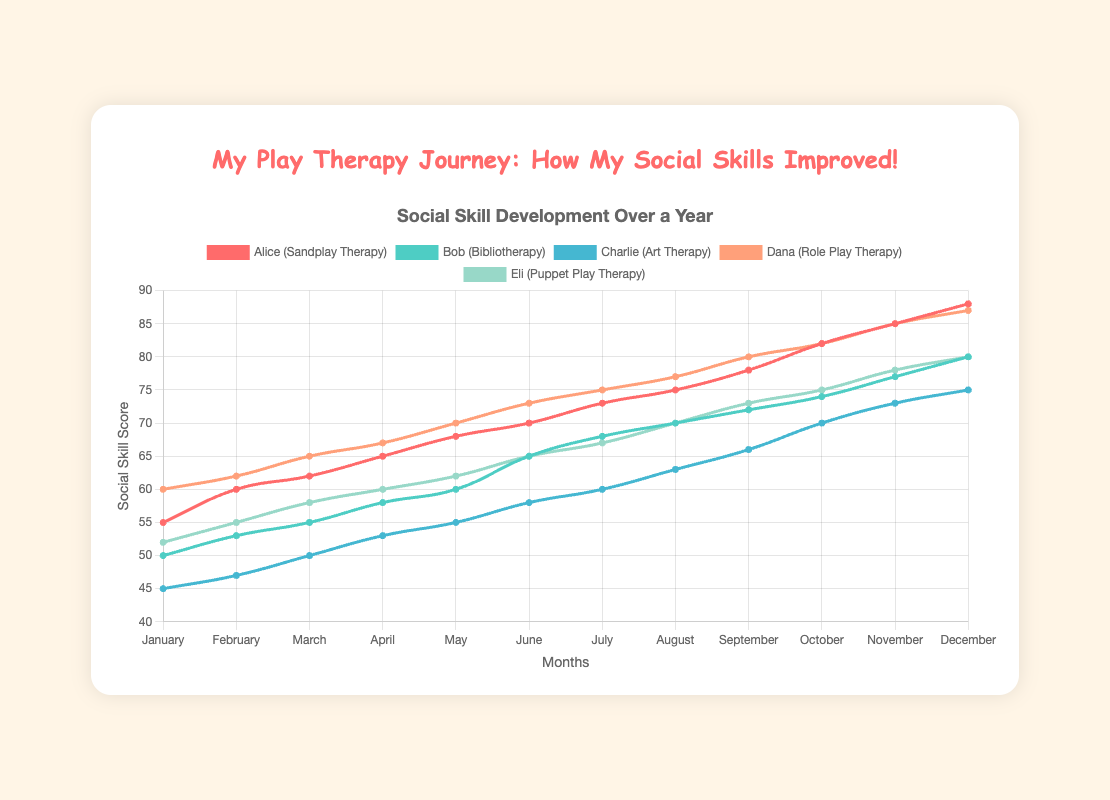Which student showed the greatest increase in their social skill score in December compared to January? To find the greatest increase, subtract the January score from the December score for each student. Alice: 88-55 = 33, Bob: 80-50 = 30, Charlie: 75-45 = 30, Dana: 87-60 = 27, Eli: 80-52 = 28. Thus, Alice shows the greatest increase.
Answer: Alice Who had the highest social skill score in October? Check the values for each student in October. Alice: 82, Bob: 74, Charlie: 70, Dana: 82, Eli: 75. Alice and Dana both have the highest score of 82.
Answer: Alice and Dana What is the average social skill score of Eli over the entire year? To find the average, sum all the scores and divide by the number of months. Eli's scores are 52, 55, 58, 60, 62, 65, 67, 70, 73, 75, 78, 80. Sum = 795. The number of months = 12, so average = 795/12 ≈ 66.25.
Answer: 66.25 Which therapy technique was associated with the lowest initial (January) social skill score? Compare the January scores. Alice (Sandplay Therapy): 55, Bob (Bibliotherapy): 50, Charlie (Art Therapy): 45, Dana (Role Play Therapy): 60, Eli (Puppet Play Therapy): 52. Charlie has the lowest score of 45 with Art Therapy.
Answer: Art Therapy Is there a month where all students had the same or increased social skill scores compared to the previous month? Check each student's scores month by month. In June, Alice: 70 (↑), Bob: 65 (↑), Charlie: 58 (↑), Dana: 73 (↑), Eli: 65 (↑). All students had increased scores in June compared to May.
Answer: June How many months did Alice have the highest social skill score among all students? Compare Alice's scores each month to the other students' scores. Alice had the highest score in April, May, October, November, and December. That's 5 months.
Answer: 5 Which student showed a decrease in their social skill score between any two consecutive months? Look through each student's score month-to-month. All students' scores either increased or stayed the same each month without any decreases.
Answer: None What is the total increase in social skill score for Bob from January to December? Subtract January's score from December's score for Bob. December: 80, January: 50. Total increase = 80 - 50 = 30.
Answer: 30 What is Dana's social skill score in September, and how does it compare to Charlie's score in the same month? Dana's score in September is 80. Charlie's score in September is 66. Dana's score is higher than Charlie's score.
Answer: Dana has a higher score Which student had the second highest social skill score in November and what was it? Check the scores for November. Alice: 85, Bob: 77, Charlie: 73, Dana: 85, Eli: 78. The highest scores are by Alice and Dana with 85, followed by Eli with 78. Thus, Eli had the second highest score of 78.
Answer: Eli, 78 